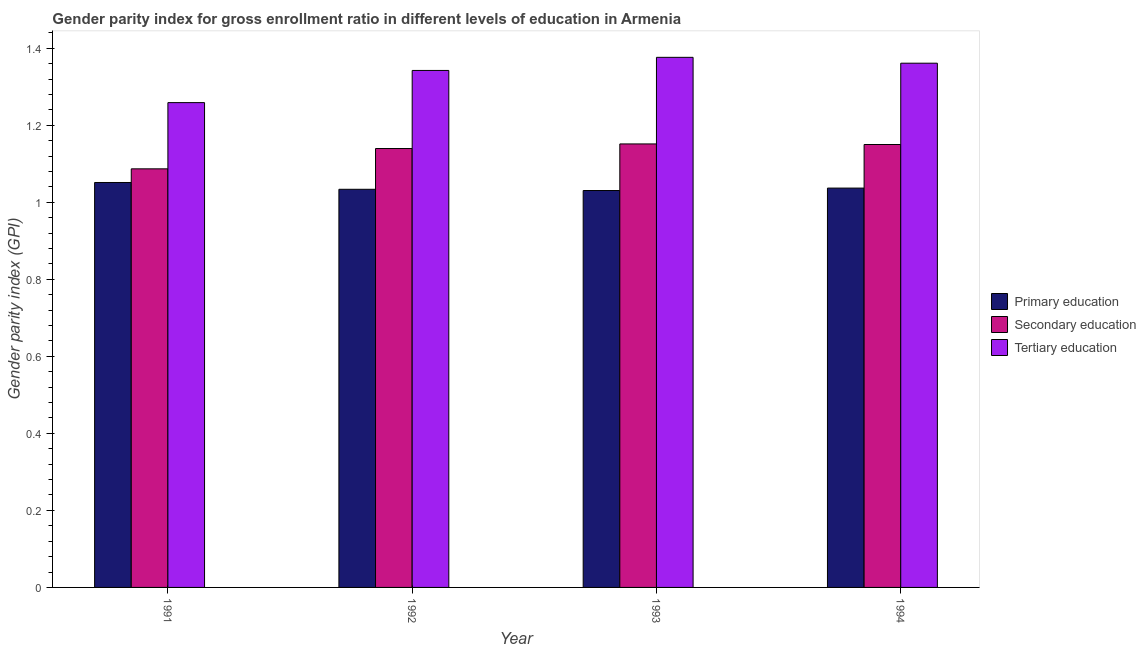Are the number of bars per tick equal to the number of legend labels?
Make the answer very short. Yes. How many bars are there on the 4th tick from the left?
Give a very brief answer. 3. How many bars are there on the 2nd tick from the right?
Ensure brevity in your answer.  3. What is the label of the 1st group of bars from the left?
Keep it short and to the point. 1991. What is the gender parity index in secondary education in 1992?
Provide a short and direct response. 1.14. Across all years, what is the maximum gender parity index in secondary education?
Ensure brevity in your answer.  1.15. Across all years, what is the minimum gender parity index in secondary education?
Ensure brevity in your answer.  1.09. In which year was the gender parity index in tertiary education maximum?
Ensure brevity in your answer.  1993. In which year was the gender parity index in secondary education minimum?
Your response must be concise. 1991. What is the total gender parity index in primary education in the graph?
Your answer should be very brief. 4.15. What is the difference between the gender parity index in primary education in 1991 and that in 1994?
Your response must be concise. 0.01. What is the difference between the gender parity index in tertiary education in 1993 and the gender parity index in primary education in 1994?
Your answer should be compact. 0.02. What is the average gender parity index in primary education per year?
Give a very brief answer. 1.04. What is the ratio of the gender parity index in primary education in 1991 to that in 1992?
Offer a very short reply. 1.02. Is the gender parity index in secondary education in 1992 less than that in 1993?
Offer a terse response. Yes. What is the difference between the highest and the second highest gender parity index in tertiary education?
Provide a short and direct response. 0.02. What is the difference between the highest and the lowest gender parity index in secondary education?
Make the answer very short. 0.06. What does the 3rd bar from the left in 1993 represents?
Ensure brevity in your answer.  Tertiary education. What does the 1st bar from the right in 1993 represents?
Your response must be concise. Tertiary education. Is it the case that in every year, the sum of the gender parity index in primary education and gender parity index in secondary education is greater than the gender parity index in tertiary education?
Offer a very short reply. Yes. How many bars are there?
Provide a short and direct response. 12. What is the difference between two consecutive major ticks on the Y-axis?
Your answer should be very brief. 0.2. Are the values on the major ticks of Y-axis written in scientific E-notation?
Make the answer very short. No. Does the graph contain any zero values?
Provide a succinct answer. No. Does the graph contain grids?
Your answer should be very brief. No. How many legend labels are there?
Give a very brief answer. 3. What is the title of the graph?
Ensure brevity in your answer.  Gender parity index for gross enrollment ratio in different levels of education in Armenia. What is the label or title of the X-axis?
Make the answer very short. Year. What is the label or title of the Y-axis?
Your response must be concise. Gender parity index (GPI). What is the Gender parity index (GPI) of Primary education in 1991?
Offer a terse response. 1.05. What is the Gender parity index (GPI) in Secondary education in 1991?
Provide a succinct answer. 1.09. What is the Gender parity index (GPI) of Tertiary education in 1991?
Make the answer very short. 1.26. What is the Gender parity index (GPI) in Primary education in 1992?
Provide a succinct answer. 1.03. What is the Gender parity index (GPI) in Secondary education in 1992?
Provide a short and direct response. 1.14. What is the Gender parity index (GPI) of Tertiary education in 1992?
Your answer should be compact. 1.34. What is the Gender parity index (GPI) of Primary education in 1993?
Your answer should be very brief. 1.03. What is the Gender parity index (GPI) in Secondary education in 1993?
Your answer should be compact. 1.15. What is the Gender parity index (GPI) of Tertiary education in 1993?
Make the answer very short. 1.38. What is the Gender parity index (GPI) in Primary education in 1994?
Your response must be concise. 1.04. What is the Gender parity index (GPI) in Secondary education in 1994?
Offer a very short reply. 1.15. What is the Gender parity index (GPI) in Tertiary education in 1994?
Your answer should be compact. 1.36. Across all years, what is the maximum Gender parity index (GPI) of Primary education?
Your answer should be very brief. 1.05. Across all years, what is the maximum Gender parity index (GPI) of Secondary education?
Provide a succinct answer. 1.15. Across all years, what is the maximum Gender parity index (GPI) in Tertiary education?
Your answer should be very brief. 1.38. Across all years, what is the minimum Gender parity index (GPI) of Primary education?
Offer a very short reply. 1.03. Across all years, what is the minimum Gender parity index (GPI) in Secondary education?
Provide a short and direct response. 1.09. Across all years, what is the minimum Gender parity index (GPI) of Tertiary education?
Provide a succinct answer. 1.26. What is the total Gender parity index (GPI) in Primary education in the graph?
Offer a terse response. 4.15. What is the total Gender parity index (GPI) in Secondary education in the graph?
Provide a succinct answer. 4.53. What is the total Gender parity index (GPI) of Tertiary education in the graph?
Give a very brief answer. 5.34. What is the difference between the Gender parity index (GPI) of Primary education in 1991 and that in 1992?
Offer a very short reply. 0.02. What is the difference between the Gender parity index (GPI) of Secondary education in 1991 and that in 1992?
Your answer should be very brief. -0.05. What is the difference between the Gender parity index (GPI) of Tertiary education in 1991 and that in 1992?
Provide a short and direct response. -0.08. What is the difference between the Gender parity index (GPI) in Primary education in 1991 and that in 1993?
Ensure brevity in your answer.  0.02. What is the difference between the Gender parity index (GPI) of Secondary education in 1991 and that in 1993?
Ensure brevity in your answer.  -0.06. What is the difference between the Gender parity index (GPI) in Tertiary education in 1991 and that in 1993?
Offer a terse response. -0.12. What is the difference between the Gender parity index (GPI) in Primary education in 1991 and that in 1994?
Your answer should be compact. 0.01. What is the difference between the Gender parity index (GPI) in Secondary education in 1991 and that in 1994?
Offer a terse response. -0.06. What is the difference between the Gender parity index (GPI) in Tertiary education in 1991 and that in 1994?
Your answer should be very brief. -0.1. What is the difference between the Gender parity index (GPI) of Primary education in 1992 and that in 1993?
Offer a terse response. 0. What is the difference between the Gender parity index (GPI) of Secondary education in 1992 and that in 1993?
Your answer should be very brief. -0.01. What is the difference between the Gender parity index (GPI) in Tertiary education in 1992 and that in 1993?
Offer a very short reply. -0.03. What is the difference between the Gender parity index (GPI) in Primary education in 1992 and that in 1994?
Provide a succinct answer. -0. What is the difference between the Gender parity index (GPI) of Secondary education in 1992 and that in 1994?
Ensure brevity in your answer.  -0.01. What is the difference between the Gender parity index (GPI) in Tertiary education in 1992 and that in 1994?
Give a very brief answer. -0.02. What is the difference between the Gender parity index (GPI) in Primary education in 1993 and that in 1994?
Offer a terse response. -0.01. What is the difference between the Gender parity index (GPI) in Secondary education in 1993 and that in 1994?
Keep it short and to the point. 0. What is the difference between the Gender parity index (GPI) of Tertiary education in 1993 and that in 1994?
Your answer should be compact. 0.02. What is the difference between the Gender parity index (GPI) of Primary education in 1991 and the Gender parity index (GPI) of Secondary education in 1992?
Provide a succinct answer. -0.09. What is the difference between the Gender parity index (GPI) in Primary education in 1991 and the Gender parity index (GPI) in Tertiary education in 1992?
Give a very brief answer. -0.29. What is the difference between the Gender parity index (GPI) of Secondary education in 1991 and the Gender parity index (GPI) of Tertiary education in 1992?
Offer a terse response. -0.26. What is the difference between the Gender parity index (GPI) in Primary education in 1991 and the Gender parity index (GPI) in Secondary education in 1993?
Provide a succinct answer. -0.1. What is the difference between the Gender parity index (GPI) of Primary education in 1991 and the Gender parity index (GPI) of Tertiary education in 1993?
Offer a terse response. -0.32. What is the difference between the Gender parity index (GPI) of Secondary education in 1991 and the Gender parity index (GPI) of Tertiary education in 1993?
Keep it short and to the point. -0.29. What is the difference between the Gender parity index (GPI) of Primary education in 1991 and the Gender parity index (GPI) of Secondary education in 1994?
Provide a short and direct response. -0.1. What is the difference between the Gender parity index (GPI) in Primary education in 1991 and the Gender parity index (GPI) in Tertiary education in 1994?
Your answer should be very brief. -0.31. What is the difference between the Gender parity index (GPI) in Secondary education in 1991 and the Gender parity index (GPI) in Tertiary education in 1994?
Give a very brief answer. -0.27. What is the difference between the Gender parity index (GPI) in Primary education in 1992 and the Gender parity index (GPI) in Secondary education in 1993?
Offer a very short reply. -0.12. What is the difference between the Gender parity index (GPI) of Primary education in 1992 and the Gender parity index (GPI) of Tertiary education in 1993?
Offer a terse response. -0.34. What is the difference between the Gender parity index (GPI) of Secondary education in 1992 and the Gender parity index (GPI) of Tertiary education in 1993?
Provide a short and direct response. -0.24. What is the difference between the Gender parity index (GPI) in Primary education in 1992 and the Gender parity index (GPI) in Secondary education in 1994?
Provide a succinct answer. -0.12. What is the difference between the Gender parity index (GPI) of Primary education in 1992 and the Gender parity index (GPI) of Tertiary education in 1994?
Ensure brevity in your answer.  -0.33. What is the difference between the Gender parity index (GPI) in Secondary education in 1992 and the Gender parity index (GPI) in Tertiary education in 1994?
Ensure brevity in your answer.  -0.22. What is the difference between the Gender parity index (GPI) in Primary education in 1993 and the Gender parity index (GPI) in Secondary education in 1994?
Ensure brevity in your answer.  -0.12. What is the difference between the Gender parity index (GPI) in Primary education in 1993 and the Gender parity index (GPI) in Tertiary education in 1994?
Your answer should be compact. -0.33. What is the difference between the Gender parity index (GPI) of Secondary education in 1993 and the Gender parity index (GPI) of Tertiary education in 1994?
Keep it short and to the point. -0.21. What is the average Gender parity index (GPI) in Primary education per year?
Ensure brevity in your answer.  1.04. What is the average Gender parity index (GPI) in Secondary education per year?
Your answer should be very brief. 1.13. What is the average Gender parity index (GPI) in Tertiary education per year?
Your answer should be compact. 1.33. In the year 1991, what is the difference between the Gender parity index (GPI) in Primary education and Gender parity index (GPI) in Secondary education?
Ensure brevity in your answer.  -0.04. In the year 1991, what is the difference between the Gender parity index (GPI) in Primary education and Gender parity index (GPI) in Tertiary education?
Keep it short and to the point. -0.21. In the year 1991, what is the difference between the Gender parity index (GPI) in Secondary education and Gender parity index (GPI) in Tertiary education?
Ensure brevity in your answer.  -0.17. In the year 1992, what is the difference between the Gender parity index (GPI) in Primary education and Gender parity index (GPI) in Secondary education?
Provide a succinct answer. -0.11. In the year 1992, what is the difference between the Gender parity index (GPI) of Primary education and Gender parity index (GPI) of Tertiary education?
Your response must be concise. -0.31. In the year 1992, what is the difference between the Gender parity index (GPI) of Secondary education and Gender parity index (GPI) of Tertiary education?
Your answer should be compact. -0.2. In the year 1993, what is the difference between the Gender parity index (GPI) of Primary education and Gender parity index (GPI) of Secondary education?
Make the answer very short. -0.12. In the year 1993, what is the difference between the Gender parity index (GPI) of Primary education and Gender parity index (GPI) of Tertiary education?
Ensure brevity in your answer.  -0.35. In the year 1993, what is the difference between the Gender parity index (GPI) of Secondary education and Gender parity index (GPI) of Tertiary education?
Your response must be concise. -0.22. In the year 1994, what is the difference between the Gender parity index (GPI) of Primary education and Gender parity index (GPI) of Secondary education?
Provide a short and direct response. -0.11. In the year 1994, what is the difference between the Gender parity index (GPI) of Primary education and Gender parity index (GPI) of Tertiary education?
Give a very brief answer. -0.32. In the year 1994, what is the difference between the Gender parity index (GPI) of Secondary education and Gender parity index (GPI) of Tertiary education?
Your response must be concise. -0.21. What is the ratio of the Gender parity index (GPI) of Primary education in 1991 to that in 1992?
Your response must be concise. 1.02. What is the ratio of the Gender parity index (GPI) in Secondary education in 1991 to that in 1992?
Ensure brevity in your answer.  0.95. What is the ratio of the Gender parity index (GPI) in Tertiary education in 1991 to that in 1992?
Your response must be concise. 0.94. What is the ratio of the Gender parity index (GPI) in Primary education in 1991 to that in 1993?
Offer a terse response. 1.02. What is the ratio of the Gender parity index (GPI) of Secondary education in 1991 to that in 1993?
Provide a short and direct response. 0.94. What is the ratio of the Gender parity index (GPI) in Tertiary education in 1991 to that in 1993?
Make the answer very short. 0.91. What is the ratio of the Gender parity index (GPI) in Primary education in 1991 to that in 1994?
Make the answer very short. 1.01. What is the ratio of the Gender parity index (GPI) in Secondary education in 1991 to that in 1994?
Keep it short and to the point. 0.95. What is the ratio of the Gender parity index (GPI) in Tertiary education in 1991 to that in 1994?
Offer a terse response. 0.92. What is the ratio of the Gender parity index (GPI) in Primary education in 1992 to that in 1993?
Offer a very short reply. 1. What is the ratio of the Gender parity index (GPI) in Tertiary education in 1992 to that in 1993?
Give a very brief answer. 0.98. What is the ratio of the Gender parity index (GPI) of Primary education in 1992 to that in 1994?
Your answer should be compact. 1. What is the ratio of the Gender parity index (GPI) of Secondary education in 1992 to that in 1994?
Keep it short and to the point. 0.99. What is the ratio of the Gender parity index (GPI) in Tertiary education in 1992 to that in 1994?
Provide a succinct answer. 0.99. What is the ratio of the Gender parity index (GPI) of Primary education in 1993 to that in 1994?
Offer a very short reply. 0.99. What is the ratio of the Gender parity index (GPI) of Tertiary education in 1993 to that in 1994?
Your response must be concise. 1.01. What is the difference between the highest and the second highest Gender parity index (GPI) in Primary education?
Make the answer very short. 0.01. What is the difference between the highest and the second highest Gender parity index (GPI) of Secondary education?
Your response must be concise. 0. What is the difference between the highest and the second highest Gender parity index (GPI) in Tertiary education?
Your answer should be very brief. 0.02. What is the difference between the highest and the lowest Gender parity index (GPI) in Primary education?
Your answer should be compact. 0.02. What is the difference between the highest and the lowest Gender parity index (GPI) of Secondary education?
Ensure brevity in your answer.  0.06. What is the difference between the highest and the lowest Gender parity index (GPI) in Tertiary education?
Ensure brevity in your answer.  0.12. 